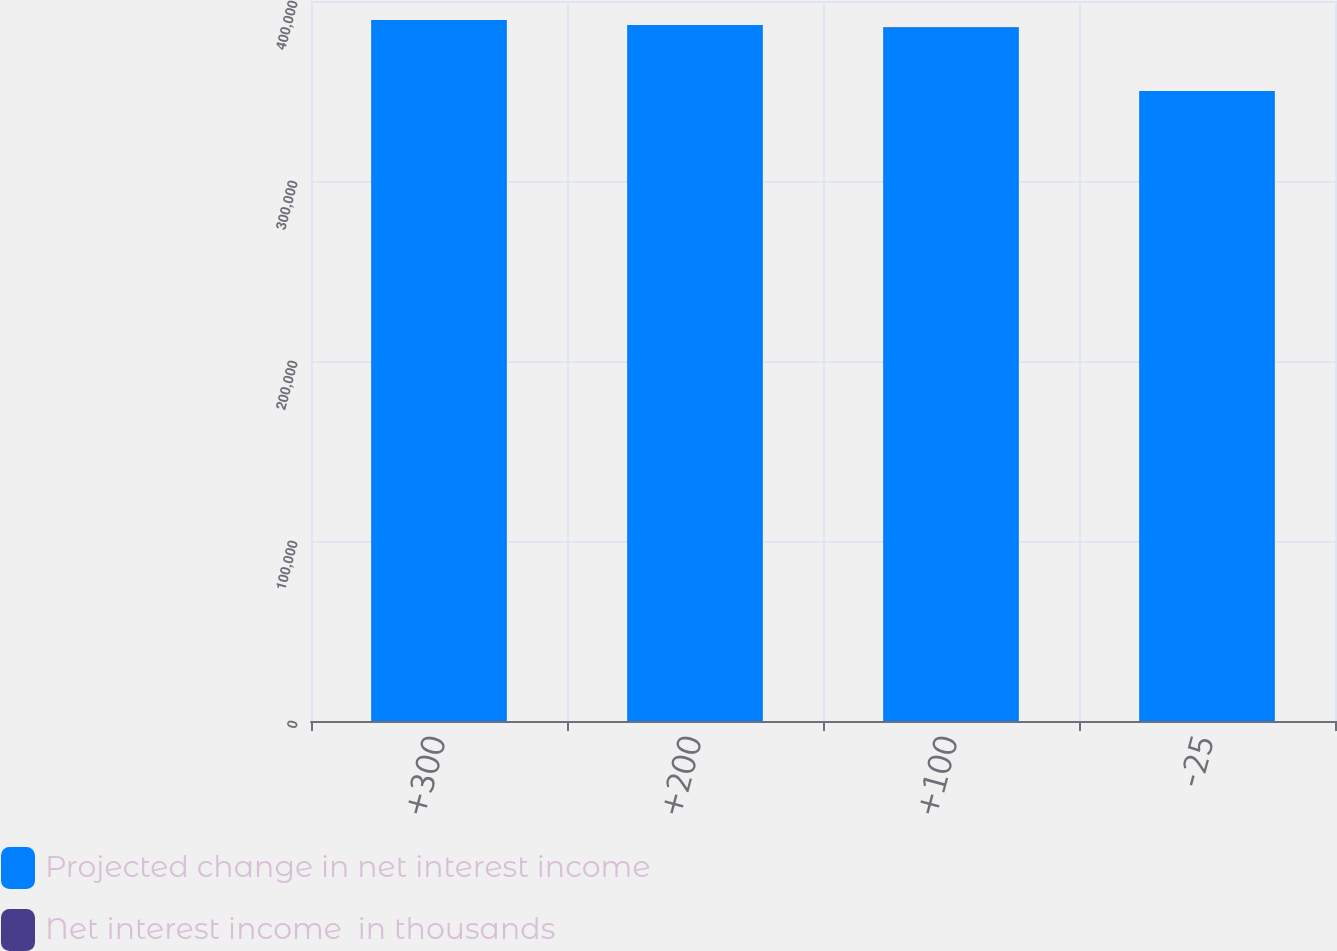Convert chart. <chart><loc_0><loc_0><loc_500><loc_500><stacked_bar_chart><ecel><fcel>+300<fcel>+200<fcel>+100<fcel>-25<nl><fcel>Projected change in net interest income<fcel>389430<fcel>386727<fcel>385480<fcel>350009<nl><fcel>Net interest income  in thousands<fcel>8.14<fcel>7.39<fcel>7.04<fcel>2.81<nl></chart> 